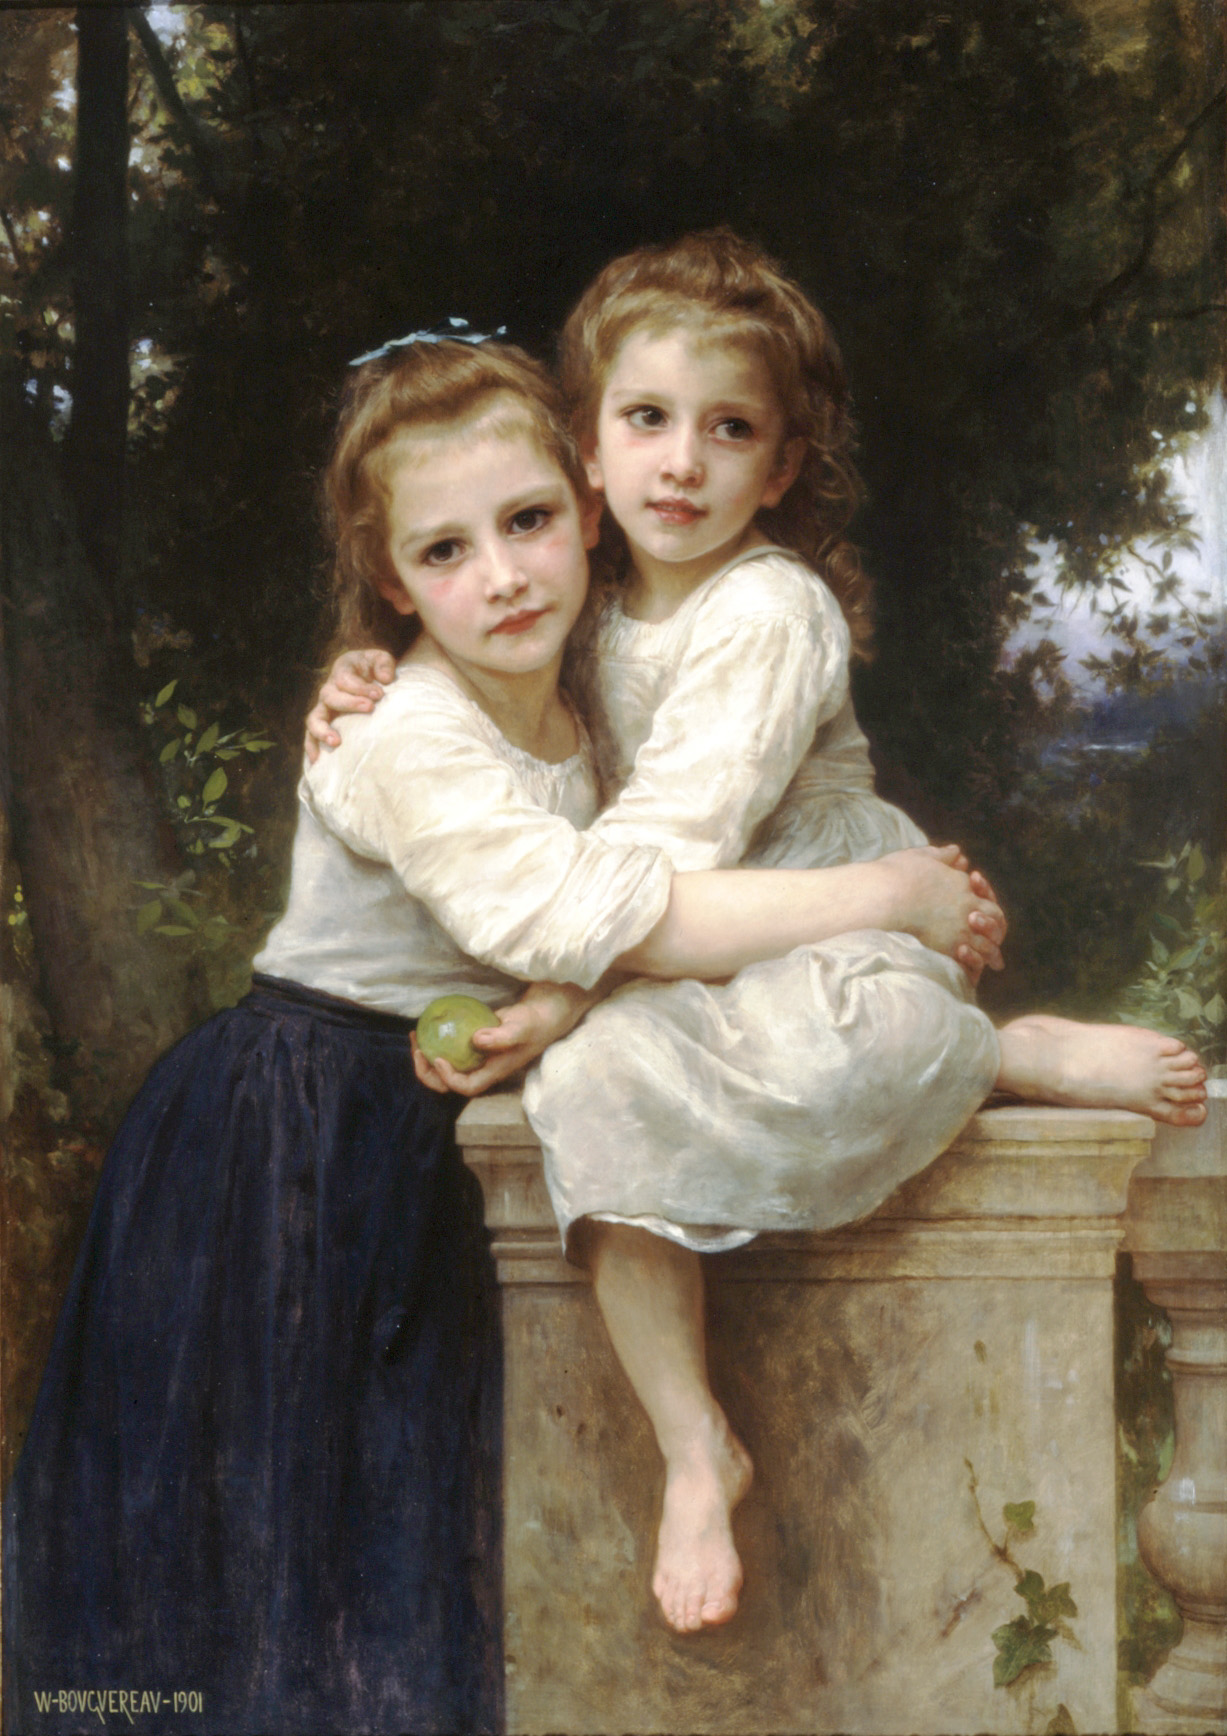Can you describe the main features of this image for me? The image is a captivating oil painting that transports us to a different era. It features two young girls, their faces glowing with innocence, locked in a tender embrace. They are perched on a stone wall, their white dresses contrasting beautifully with the verdant backdrop. Their hair, neatly tied back with blue ribbons, adds a touch of color to the otherwise monochromatic attire. The lush garden in the background, teeming with trees and bushes, lends a sense of tranquility to the scene. The painting, executed in the style of realism, exudes a sense of nostalgia, likely harking back to the 19th century. The artist's skillful use of light and shadow, along with the meticulous attention to detail, enhances the lifelike quality of the painting. The overall composition, with its harmonious blend of colors and textures, creates a visually pleasing tableau that is both engaging and evocative. 